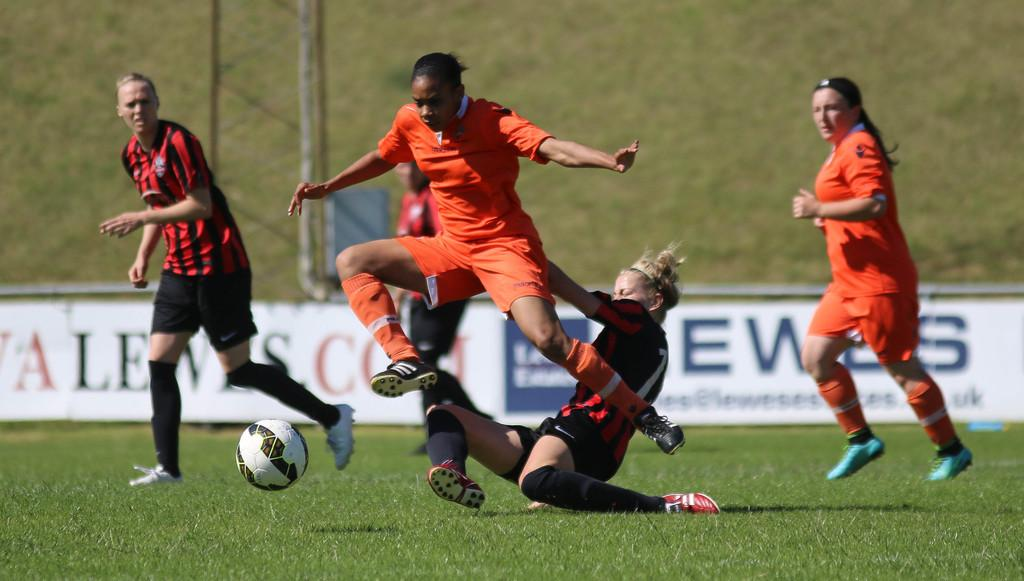What activity are the people in the image engaged in? The people in the image are playing football. What is the main object used in the game? There is a football in the image. What can be seen in the background of the image? There is a pole in the image. What is attached to the object in the image? There are banners attached to an object in the image. What type of light can be seen emanating from the football in the image? There is no light emanating from the football in the image. What force is being applied to the pole in the image? The image does not show any force being applied to the pole; it is stationary. 